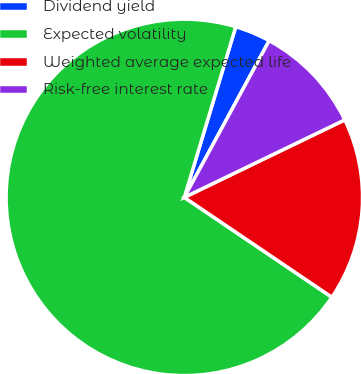<chart> <loc_0><loc_0><loc_500><loc_500><pie_chart><fcel>Dividend yield<fcel>Expected volatility<fcel>Weighted average expected life<fcel>Risk-free interest rate<nl><fcel>3.24%<fcel>70.19%<fcel>16.63%<fcel>9.94%<nl></chart> 